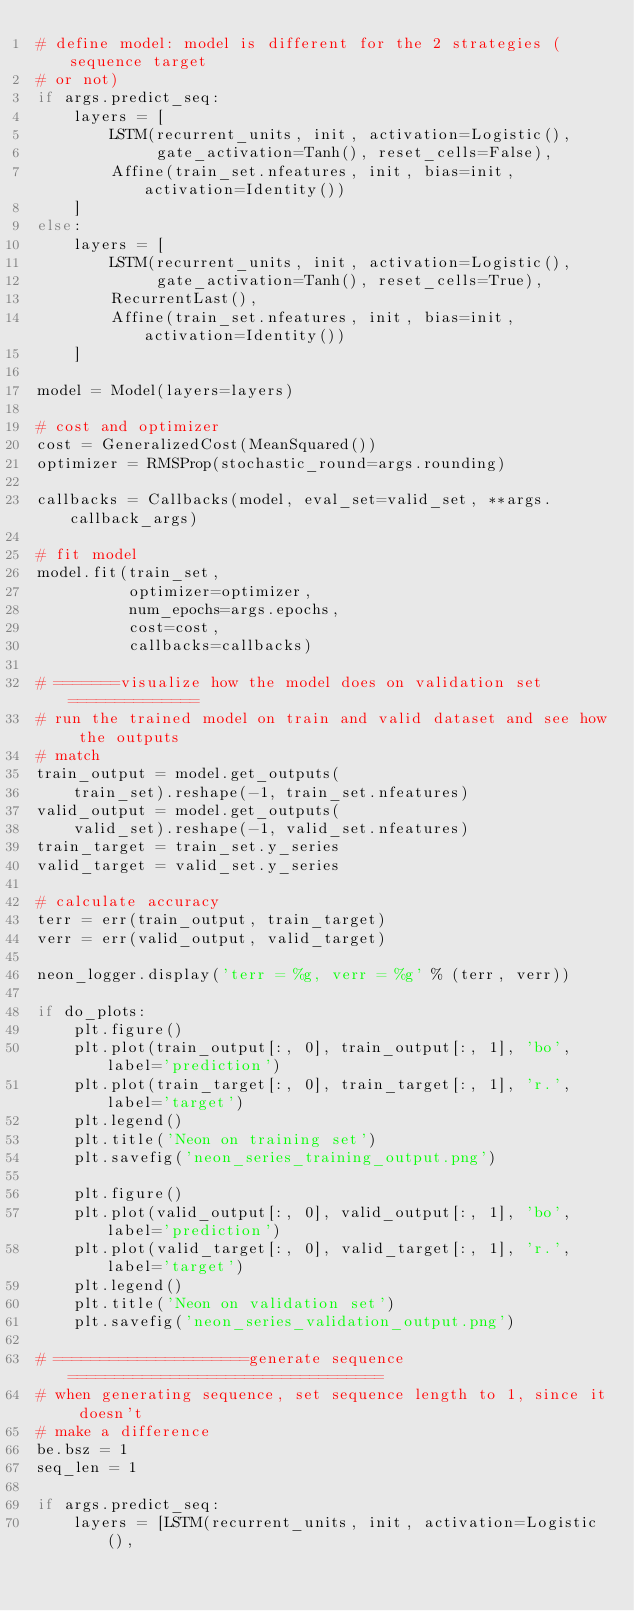<code> <loc_0><loc_0><loc_500><loc_500><_Python_># define model: model is different for the 2 strategies (sequence target
# or not)
if args.predict_seq:
    layers = [
        LSTM(recurrent_units, init, activation=Logistic(),
             gate_activation=Tanh(), reset_cells=False),
        Affine(train_set.nfeatures, init, bias=init, activation=Identity())
    ]
else:
    layers = [
        LSTM(recurrent_units, init, activation=Logistic(),
             gate_activation=Tanh(), reset_cells=True),
        RecurrentLast(),
        Affine(train_set.nfeatures, init, bias=init, activation=Identity())
    ]

model = Model(layers=layers)

# cost and optimizer
cost = GeneralizedCost(MeanSquared())
optimizer = RMSProp(stochastic_round=args.rounding)

callbacks = Callbacks(model, eval_set=valid_set, **args.callback_args)

# fit model
model.fit(train_set,
          optimizer=optimizer,
          num_epochs=args.epochs,
          cost=cost,
          callbacks=callbacks)

# =======visualize how the model does on validation set==============
# run the trained model on train and valid dataset and see how the outputs
# match
train_output = model.get_outputs(
    train_set).reshape(-1, train_set.nfeatures)
valid_output = model.get_outputs(
    valid_set).reshape(-1, valid_set.nfeatures)
train_target = train_set.y_series
valid_target = valid_set.y_series

# calculate accuracy
terr = err(train_output, train_target)
verr = err(valid_output, valid_target)

neon_logger.display('terr = %g, verr = %g' % (terr, verr))

if do_plots:
    plt.figure()
    plt.plot(train_output[:, 0], train_output[:, 1], 'bo', label='prediction')
    plt.plot(train_target[:, 0], train_target[:, 1], 'r.', label='target')
    plt.legend()
    plt.title('Neon on training set')
    plt.savefig('neon_series_training_output.png')

    plt.figure()
    plt.plot(valid_output[:, 0], valid_output[:, 1], 'bo', label='prediction')
    plt.plot(valid_target[:, 0], valid_target[:, 1], 'r.', label='target')
    plt.legend()
    plt.title('Neon on validation set')
    plt.savefig('neon_series_validation_output.png')

# =====================generate sequence ==================================
# when generating sequence, set sequence length to 1, since it doesn't
# make a difference
be.bsz = 1
seq_len = 1

if args.predict_seq:
    layers = [LSTM(recurrent_units, init, activation=Logistic(),</code> 